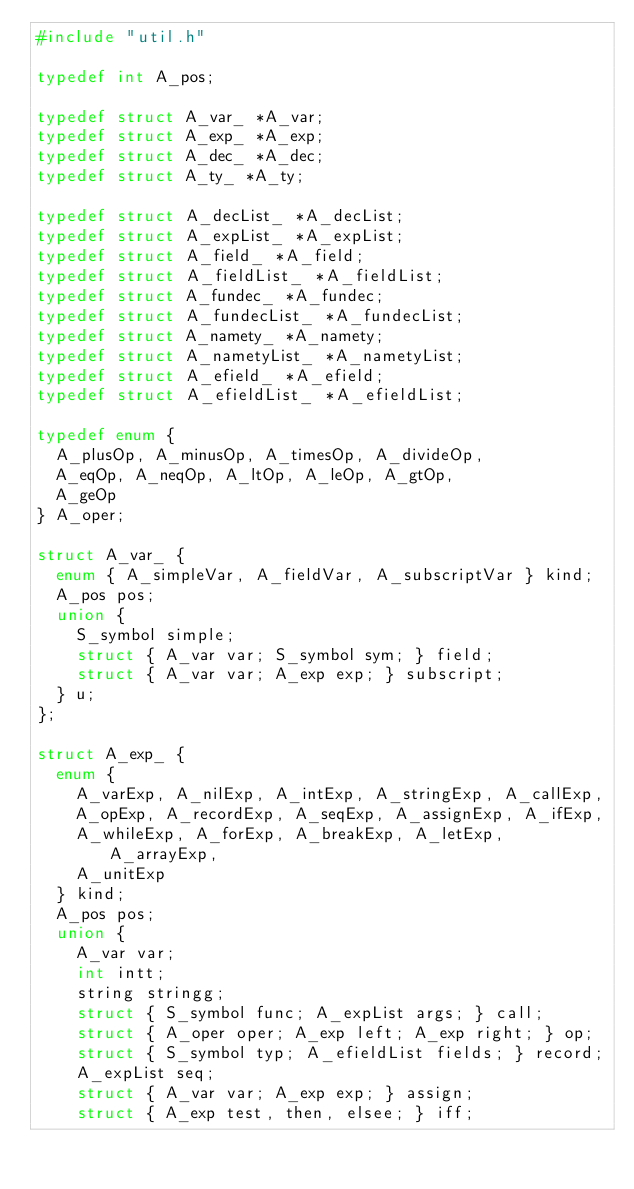<code> <loc_0><loc_0><loc_500><loc_500><_C_>#include "util.h"

typedef int A_pos;

typedef struct A_var_ *A_var;
typedef struct A_exp_ *A_exp;
typedef struct A_dec_ *A_dec;
typedef struct A_ty_ *A_ty;

typedef struct A_decList_ *A_decList;
typedef struct A_expList_ *A_expList;
typedef struct A_field_ *A_field;
typedef struct A_fieldList_ *A_fieldList;
typedef struct A_fundec_ *A_fundec;
typedef struct A_fundecList_ *A_fundecList;
typedef struct A_namety_ *A_namety;
typedef struct A_nametyList_ *A_nametyList;
typedef struct A_efield_ *A_efield;
typedef struct A_efieldList_ *A_efieldList;

typedef enum {
	A_plusOp, A_minusOp, A_timesOp, A_divideOp,
	A_eqOp, A_neqOp, A_ltOp, A_leOp, A_gtOp,
	A_geOp
} A_oper;

struct A_var_ {
	enum { A_simpleVar, A_fieldVar, A_subscriptVar } kind;
	A_pos pos;
	union {
		S_symbol simple;
		struct { A_var var; S_symbol sym; } field;
		struct { A_var var; A_exp exp; } subscript;
	} u;
};

struct A_exp_ {
	enum {
		A_varExp, A_nilExp, A_intExp, A_stringExp, A_callExp,
		A_opExp, A_recordExp, A_seqExp, A_assignExp, A_ifExp,
		A_whileExp, A_forExp, A_breakExp, A_letExp, A_arrayExp,
		A_unitExp
	} kind;
	A_pos pos;
	union {
		A_var var;
		int intt;
		string stringg;
		struct { S_symbol func; A_expList args; } call;
		struct { A_oper oper; A_exp left; A_exp right; } op;
		struct { S_symbol typ; A_efieldList fields; } record;
		A_expList seq;
		struct { A_var var; A_exp exp; } assign;
		struct { A_exp test, then, elsee; } iff;</code> 